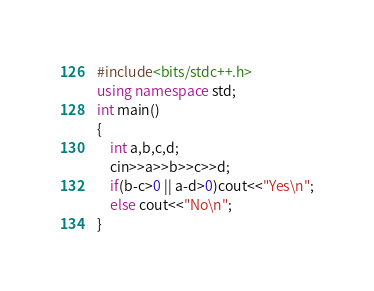Convert code to text. <code><loc_0><loc_0><loc_500><loc_500><_C++_>#include<bits/stdc++.h>
using namespace std;
int main()
{
    int a,b,c,d;
    cin>>a>>b>>c>>d;
    if(b-c>0 || a-d>0)cout<<"Yes\n";
    else cout<<"No\n";
}
</code> 